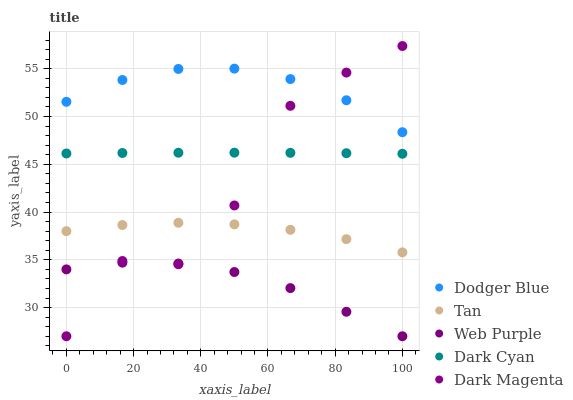Does Web Purple have the minimum area under the curve?
Answer yes or no. Yes. Does Dodger Blue have the maximum area under the curve?
Answer yes or no. Yes. Does Tan have the minimum area under the curve?
Answer yes or no. No. Does Tan have the maximum area under the curve?
Answer yes or no. No. Is Dark Cyan the smoothest?
Answer yes or no. Yes. Is Dark Magenta the roughest?
Answer yes or no. Yes. Is Tan the smoothest?
Answer yes or no. No. Is Tan the roughest?
Answer yes or no. No. Does Web Purple have the lowest value?
Answer yes or no. Yes. Does Tan have the lowest value?
Answer yes or no. No. Does Dark Magenta have the highest value?
Answer yes or no. Yes. Does Tan have the highest value?
Answer yes or no. No. Is Dark Cyan less than Dodger Blue?
Answer yes or no. Yes. Is Tan greater than Web Purple?
Answer yes or no. Yes. Does Dodger Blue intersect Dark Magenta?
Answer yes or no. Yes. Is Dodger Blue less than Dark Magenta?
Answer yes or no. No. Is Dodger Blue greater than Dark Magenta?
Answer yes or no. No. Does Dark Cyan intersect Dodger Blue?
Answer yes or no. No. 